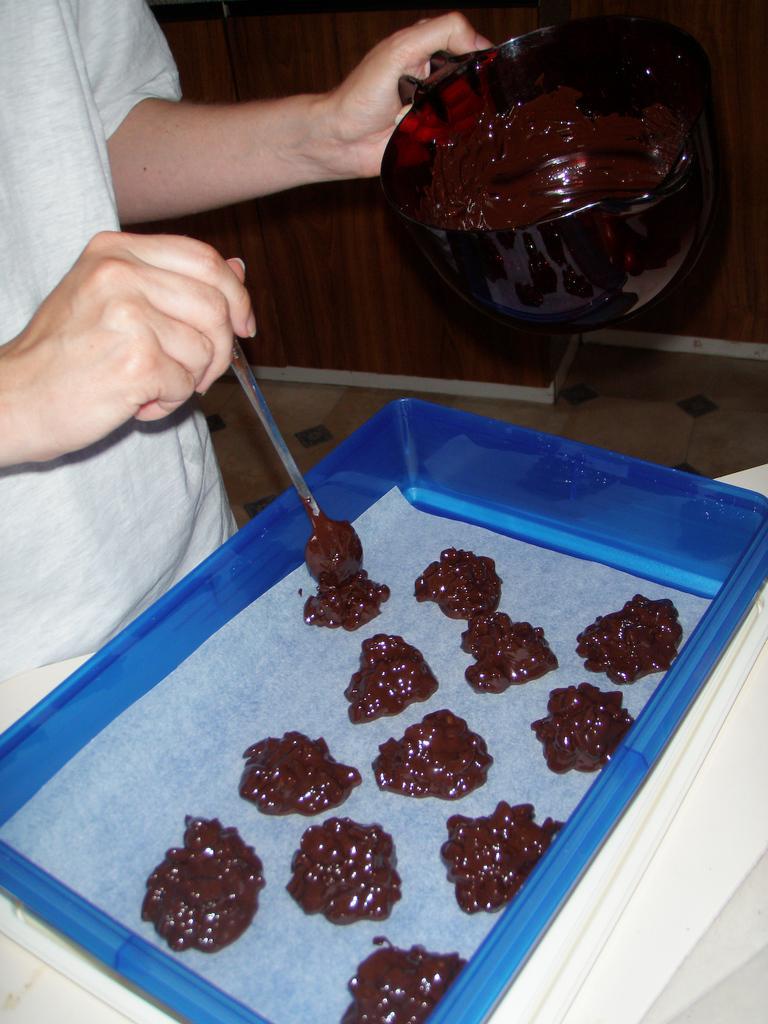In one or two sentences, can you explain what this image depicts? In this picture there is a person on the left side of the image, by holding a spoon, it seems to be a bowl of chocolate in his another hand and there is a tray in front of him, in which he is placing the chocolate. 